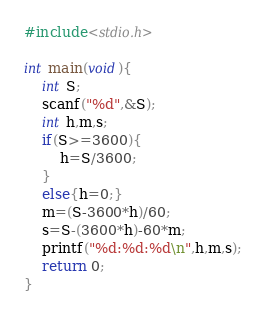Convert code to text. <code><loc_0><loc_0><loc_500><loc_500><_C_>#include<stdio.h>

int main(void){
	int S;
	scanf("%d",&S);
	int h,m,s;
	if(S>=3600){
		h=S/3600;
	}
	else{h=0;}
	m=(S-3600*h)/60;
	s=S-(3600*h)-60*m;
	printf("%d:%d:%d\n",h,m,s);
	return 0;
}
</code> 